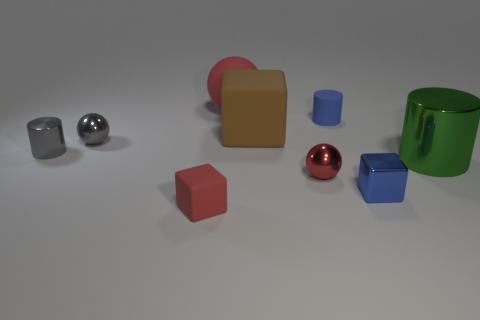Subtract all green cylinders. How many cylinders are left? 2 Subtract all large red spheres. How many spheres are left? 2 Subtract 0 brown balls. How many objects are left? 9 Subtract all blocks. How many objects are left? 6 Subtract 1 cubes. How many cubes are left? 2 Subtract all cyan cylinders. Subtract all brown blocks. How many cylinders are left? 3 Subtract all gray balls. How many brown cylinders are left? 0 Subtract all tiny green objects. Subtract all large brown rubber things. How many objects are left? 8 Add 7 small metal cylinders. How many small metal cylinders are left? 8 Add 9 large cylinders. How many large cylinders exist? 10 